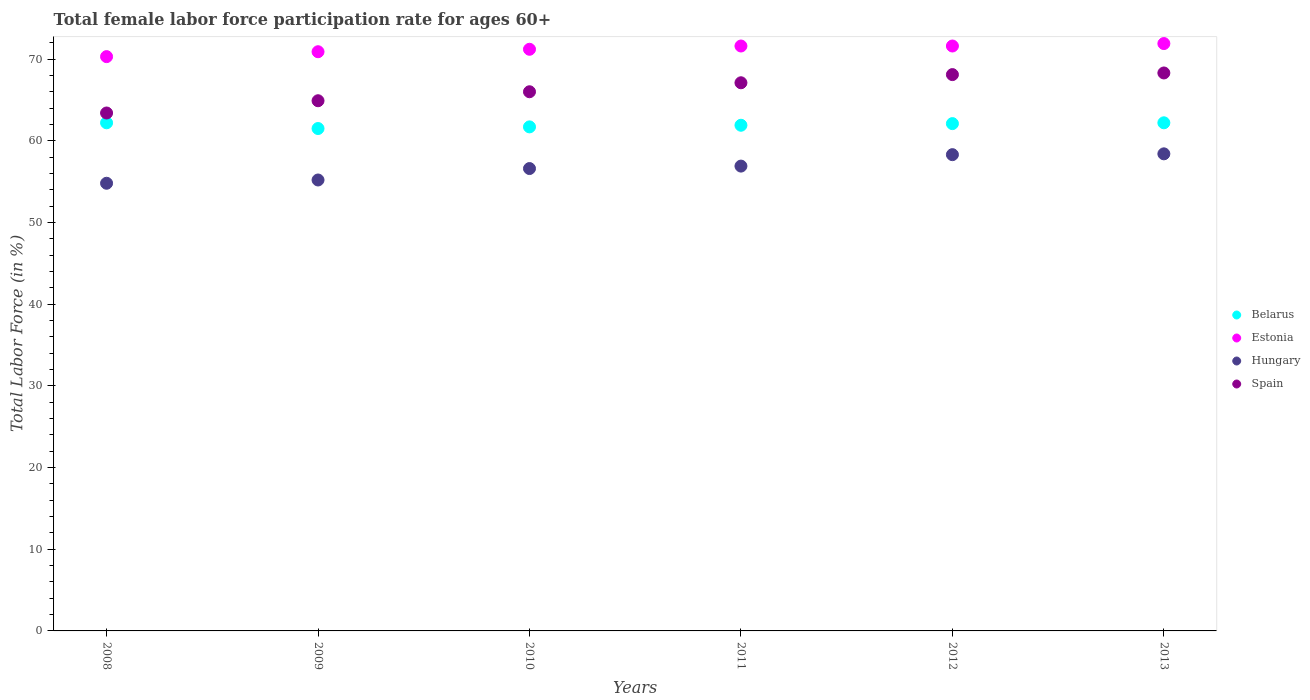How many different coloured dotlines are there?
Offer a very short reply. 4. Is the number of dotlines equal to the number of legend labels?
Ensure brevity in your answer.  Yes. What is the female labor force participation rate in Belarus in 2012?
Ensure brevity in your answer.  62.1. Across all years, what is the maximum female labor force participation rate in Hungary?
Provide a short and direct response. 58.4. Across all years, what is the minimum female labor force participation rate in Estonia?
Ensure brevity in your answer.  70.3. In which year was the female labor force participation rate in Spain minimum?
Give a very brief answer. 2008. What is the total female labor force participation rate in Hungary in the graph?
Offer a very short reply. 340.2. What is the difference between the female labor force participation rate in Estonia in 2008 and that in 2013?
Your answer should be very brief. -1.6. What is the average female labor force participation rate in Belarus per year?
Offer a terse response. 61.93. In the year 2012, what is the difference between the female labor force participation rate in Spain and female labor force participation rate in Hungary?
Your response must be concise. 9.8. What is the ratio of the female labor force participation rate in Estonia in 2011 to that in 2012?
Offer a terse response. 1. What is the difference between the highest and the second highest female labor force participation rate in Spain?
Keep it short and to the point. 0.2. What is the difference between the highest and the lowest female labor force participation rate in Spain?
Give a very brief answer. 4.9. In how many years, is the female labor force participation rate in Estonia greater than the average female labor force participation rate in Estonia taken over all years?
Make the answer very short. 3. Is it the case that in every year, the sum of the female labor force participation rate in Belarus and female labor force participation rate in Spain  is greater than the sum of female labor force participation rate in Estonia and female labor force participation rate in Hungary?
Provide a succinct answer. Yes. Does the female labor force participation rate in Spain monotonically increase over the years?
Keep it short and to the point. Yes. Is the female labor force participation rate in Hungary strictly less than the female labor force participation rate in Estonia over the years?
Give a very brief answer. Yes. How many dotlines are there?
Provide a short and direct response. 4. How many years are there in the graph?
Provide a short and direct response. 6. Are the values on the major ticks of Y-axis written in scientific E-notation?
Your answer should be compact. No. Does the graph contain grids?
Your answer should be compact. No. Where does the legend appear in the graph?
Keep it short and to the point. Center right. How many legend labels are there?
Your answer should be very brief. 4. What is the title of the graph?
Offer a terse response. Total female labor force participation rate for ages 60+. Does "Dominica" appear as one of the legend labels in the graph?
Offer a terse response. No. What is the label or title of the X-axis?
Offer a terse response. Years. What is the label or title of the Y-axis?
Ensure brevity in your answer.  Total Labor Force (in %). What is the Total Labor Force (in %) of Belarus in 2008?
Ensure brevity in your answer.  62.2. What is the Total Labor Force (in %) of Estonia in 2008?
Give a very brief answer. 70.3. What is the Total Labor Force (in %) of Hungary in 2008?
Your response must be concise. 54.8. What is the Total Labor Force (in %) of Spain in 2008?
Offer a very short reply. 63.4. What is the Total Labor Force (in %) of Belarus in 2009?
Ensure brevity in your answer.  61.5. What is the Total Labor Force (in %) of Estonia in 2009?
Offer a very short reply. 70.9. What is the Total Labor Force (in %) of Hungary in 2009?
Your answer should be compact. 55.2. What is the Total Labor Force (in %) in Spain in 2009?
Offer a terse response. 64.9. What is the Total Labor Force (in %) in Belarus in 2010?
Provide a short and direct response. 61.7. What is the Total Labor Force (in %) of Estonia in 2010?
Keep it short and to the point. 71.2. What is the Total Labor Force (in %) of Hungary in 2010?
Make the answer very short. 56.6. What is the Total Labor Force (in %) of Belarus in 2011?
Your response must be concise. 61.9. What is the Total Labor Force (in %) in Estonia in 2011?
Ensure brevity in your answer.  71.6. What is the Total Labor Force (in %) of Hungary in 2011?
Provide a short and direct response. 56.9. What is the Total Labor Force (in %) of Spain in 2011?
Your response must be concise. 67.1. What is the Total Labor Force (in %) in Belarus in 2012?
Give a very brief answer. 62.1. What is the Total Labor Force (in %) of Estonia in 2012?
Offer a very short reply. 71.6. What is the Total Labor Force (in %) of Hungary in 2012?
Ensure brevity in your answer.  58.3. What is the Total Labor Force (in %) of Spain in 2012?
Make the answer very short. 68.1. What is the Total Labor Force (in %) of Belarus in 2013?
Make the answer very short. 62.2. What is the Total Labor Force (in %) of Estonia in 2013?
Provide a short and direct response. 71.9. What is the Total Labor Force (in %) in Hungary in 2013?
Your response must be concise. 58.4. What is the Total Labor Force (in %) of Spain in 2013?
Provide a succinct answer. 68.3. Across all years, what is the maximum Total Labor Force (in %) in Belarus?
Provide a short and direct response. 62.2. Across all years, what is the maximum Total Labor Force (in %) in Estonia?
Provide a short and direct response. 71.9. Across all years, what is the maximum Total Labor Force (in %) in Hungary?
Your response must be concise. 58.4. Across all years, what is the maximum Total Labor Force (in %) of Spain?
Make the answer very short. 68.3. Across all years, what is the minimum Total Labor Force (in %) of Belarus?
Offer a very short reply. 61.5. Across all years, what is the minimum Total Labor Force (in %) of Estonia?
Provide a short and direct response. 70.3. Across all years, what is the minimum Total Labor Force (in %) of Hungary?
Your answer should be compact. 54.8. Across all years, what is the minimum Total Labor Force (in %) of Spain?
Your response must be concise. 63.4. What is the total Total Labor Force (in %) in Belarus in the graph?
Your response must be concise. 371.6. What is the total Total Labor Force (in %) of Estonia in the graph?
Give a very brief answer. 427.5. What is the total Total Labor Force (in %) of Hungary in the graph?
Your response must be concise. 340.2. What is the total Total Labor Force (in %) of Spain in the graph?
Make the answer very short. 397.8. What is the difference between the Total Labor Force (in %) of Estonia in 2008 and that in 2009?
Make the answer very short. -0.6. What is the difference between the Total Labor Force (in %) in Hungary in 2008 and that in 2010?
Provide a short and direct response. -1.8. What is the difference between the Total Labor Force (in %) of Belarus in 2008 and that in 2011?
Ensure brevity in your answer.  0.3. What is the difference between the Total Labor Force (in %) in Belarus in 2008 and that in 2012?
Keep it short and to the point. 0.1. What is the difference between the Total Labor Force (in %) in Belarus in 2008 and that in 2013?
Give a very brief answer. 0. What is the difference between the Total Labor Force (in %) in Spain in 2009 and that in 2010?
Your response must be concise. -1.1. What is the difference between the Total Labor Force (in %) of Belarus in 2009 and that in 2011?
Offer a very short reply. -0.4. What is the difference between the Total Labor Force (in %) in Hungary in 2009 and that in 2011?
Offer a terse response. -1.7. What is the difference between the Total Labor Force (in %) of Spain in 2009 and that in 2011?
Provide a short and direct response. -2.2. What is the difference between the Total Labor Force (in %) of Hungary in 2009 and that in 2012?
Keep it short and to the point. -3.1. What is the difference between the Total Labor Force (in %) in Belarus in 2009 and that in 2013?
Ensure brevity in your answer.  -0.7. What is the difference between the Total Labor Force (in %) of Hungary in 2009 and that in 2013?
Provide a succinct answer. -3.2. What is the difference between the Total Labor Force (in %) in Spain in 2009 and that in 2013?
Offer a very short reply. -3.4. What is the difference between the Total Labor Force (in %) of Hungary in 2010 and that in 2011?
Keep it short and to the point. -0.3. What is the difference between the Total Labor Force (in %) of Spain in 2010 and that in 2011?
Offer a very short reply. -1.1. What is the difference between the Total Labor Force (in %) in Belarus in 2010 and that in 2012?
Your response must be concise. -0.4. What is the difference between the Total Labor Force (in %) in Hungary in 2010 and that in 2013?
Your answer should be compact. -1.8. What is the difference between the Total Labor Force (in %) in Belarus in 2011 and that in 2013?
Provide a succinct answer. -0.3. What is the difference between the Total Labor Force (in %) of Estonia in 2011 and that in 2013?
Offer a terse response. -0.3. What is the difference between the Total Labor Force (in %) of Hungary in 2011 and that in 2013?
Make the answer very short. -1.5. What is the difference between the Total Labor Force (in %) in Spain in 2011 and that in 2013?
Keep it short and to the point. -1.2. What is the difference between the Total Labor Force (in %) of Belarus in 2012 and that in 2013?
Give a very brief answer. -0.1. What is the difference between the Total Labor Force (in %) in Estonia in 2012 and that in 2013?
Your answer should be compact. -0.3. What is the difference between the Total Labor Force (in %) in Belarus in 2008 and the Total Labor Force (in %) in Hungary in 2009?
Offer a very short reply. 7. What is the difference between the Total Labor Force (in %) in Estonia in 2008 and the Total Labor Force (in %) in Hungary in 2009?
Offer a terse response. 15.1. What is the difference between the Total Labor Force (in %) in Estonia in 2008 and the Total Labor Force (in %) in Spain in 2009?
Your answer should be compact. 5.4. What is the difference between the Total Labor Force (in %) in Hungary in 2008 and the Total Labor Force (in %) in Spain in 2009?
Offer a terse response. -10.1. What is the difference between the Total Labor Force (in %) of Belarus in 2008 and the Total Labor Force (in %) of Estonia in 2010?
Offer a very short reply. -9. What is the difference between the Total Labor Force (in %) of Estonia in 2008 and the Total Labor Force (in %) of Hungary in 2010?
Offer a very short reply. 13.7. What is the difference between the Total Labor Force (in %) of Belarus in 2008 and the Total Labor Force (in %) of Estonia in 2011?
Ensure brevity in your answer.  -9.4. What is the difference between the Total Labor Force (in %) of Estonia in 2008 and the Total Labor Force (in %) of Spain in 2011?
Your response must be concise. 3.2. What is the difference between the Total Labor Force (in %) of Hungary in 2008 and the Total Labor Force (in %) of Spain in 2011?
Provide a succinct answer. -12.3. What is the difference between the Total Labor Force (in %) in Belarus in 2008 and the Total Labor Force (in %) in Estonia in 2012?
Give a very brief answer. -9.4. What is the difference between the Total Labor Force (in %) of Estonia in 2008 and the Total Labor Force (in %) of Hungary in 2012?
Ensure brevity in your answer.  12. What is the difference between the Total Labor Force (in %) in Estonia in 2008 and the Total Labor Force (in %) in Spain in 2012?
Your response must be concise. 2.2. What is the difference between the Total Labor Force (in %) of Hungary in 2008 and the Total Labor Force (in %) of Spain in 2012?
Your answer should be compact. -13.3. What is the difference between the Total Labor Force (in %) in Belarus in 2008 and the Total Labor Force (in %) in Hungary in 2013?
Ensure brevity in your answer.  3.8. What is the difference between the Total Labor Force (in %) in Estonia in 2008 and the Total Labor Force (in %) in Hungary in 2013?
Your answer should be compact. 11.9. What is the difference between the Total Labor Force (in %) of Estonia in 2008 and the Total Labor Force (in %) of Spain in 2013?
Your answer should be very brief. 2. What is the difference between the Total Labor Force (in %) in Hungary in 2008 and the Total Labor Force (in %) in Spain in 2013?
Your answer should be compact. -13.5. What is the difference between the Total Labor Force (in %) of Belarus in 2009 and the Total Labor Force (in %) of Hungary in 2010?
Your response must be concise. 4.9. What is the difference between the Total Labor Force (in %) in Estonia in 2009 and the Total Labor Force (in %) in Hungary in 2010?
Offer a very short reply. 14.3. What is the difference between the Total Labor Force (in %) of Hungary in 2009 and the Total Labor Force (in %) of Spain in 2010?
Your answer should be compact. -10.8. What is the difference between the Total Labor Force (in %) of Belarus in 2009 and the Total Labor Force (in %) of Estonia in 2011?
Your answer should be compact. -10.1. What is the difference between the Total Labor Force (in %) of Belarus in 2009 and the Total Labor Force (in %) of Spain in 2011?
Your answer should be very brief. -5.6. What is the difference between the Total Labor Force (in %) in Estonia in 2009 and the Total Labor Force (in %) in Hungary in 2011?
Your answer should be compact. 14. What is the difference between the Total Labor Force (in %) of Belarus in 2009 and the Total Labor Force (in %) of Estonia in 2012?
Make the answer very short. -10.1. What is the difference between the Total Labor Force (in %) of Belarus in 2009 and the Total Labor Force (in %) of Spain in 2012?
Give a very brief answer. -6.6. What is the difference between the Total Labor Force (in %) in Estonia in 2009 and the Total Labor Force (in %) in Hungary in 2012?
Provide a succinct answer. 12.6. What is the difference between the Total Labor Force (in %) in Hungary in 2009 and the Total Labor Force (in %) in Spain in 2012?
Offer a terse response. -12.9. What is the difference between the Total Labor Force (in %) in Belarus in 2009 and the Total Labor Force (in %) in Hungary in 2013?
Give a very brief answer. 3.1. What is the difference between the Total Labor Force (in %) in Estonia in 2009 and the Total Labor Force (in %) in Hungary in 2013?
Keep it short and to the point. 12.5. What is the difference between the Total Labor Force (in %) in Estonia in 2009 and the Total Labor Force (in %) in Spain in 2013?
Ensure brevity in your answer.  2.6. What is the difference between the Total Labor Force (in %) of Hungary in 2009 and the Total Labor Force (in %) of Spain in 2013?
Offer a very short reply. -13.1. What is the difference between the Total Labor Force (in %) of Belarus in 2010 and the Total Labor Force (in %) of Estonia in 2011?
Provide a short and direct response. -9.9. What is the difference between the Total Labor Force (in %) in Belarus in 2010 and the Total Labor Force (in %) in Spain in 2011?
Provide a succinct answer. -5.4. What is the difference between the Total Labor Force (in %) of Estonia in 2010 and the Total Labor Force (in %) of Hungary in 2011?
Offer a terse response. 14.3. What is the difference between the Total Labor Force (in %) of Hungary in 2010 and the Total Labor Force (in %) of Spain in 2011?
Your answer should be very brief. -10.5. What is the difference between the Total Labor Force (in %) in Belarus in 2010 and the Total Labor Force (in %) in Estonia in 2012?
Keep it short and to the point. -9.9. What is the difference between the Total Labor Force (in %) in Estonia in 2010 and the Total Labor Force (in %) in Hungary in 2012?
Provide a short and direct response. 12.9. What is the difference between the Total Labor Force (in %) of Belarus in 2010 and the Total Labor Force (in %) of Hungary in 2013?
Offer a very short reply. 3.3. What is the difference between the Total Labor Force (in %) in Belarus in 2011 and the Total Labor Force (in %) in Hungary in 2012?
Provide a short and direct response. 3.6. What is the difference between the Total Labor Force (in %) in Belarus in 2011 and the Total Labor Force (in %) in Spain in 2012?
Give a very brief answer. -6.2. What is the difference between the Total Labor Force (in %) of Hungary in 2011 and the Total Labor Force (in %) of Spain in 2012?
Ensure brevity in your answer.  -11.2. What is the difference between the Total Labor Force (in %) in Belarus in 2011 and the Total Labor Force (in %) in Hungary in 2013?
Keep it short and to the point. 3.5. What is the difference between the Total Labor Force (in %) of Estonia in 2011 and the Total Labor Force (in %) of Hungary in 2013?
Give a very brief answer. 13.2. What is the difference between the Total Labor Force (in %) of Estonia in 2011 and the Total Labor Force (in %) of Spain in 2013?
Keep it short and to the point. 3.3. What is the difference between the Total Labor Force (in %) in Hungary in 2011 and the Total Labor Force (in %) in Spain in 2013?
Your answer should be compact. -11.4. What is the difference between the Total Labor Force (in %) of Belarus in 2012 and the Total Labor Force (in %) of Estonia in 2013?
Your answer should be compact. -9.8. What is the difference between the Total Labor Force (in %) of Belarus in 2012 and the Total Labor Force (in %) of Hungary in 2013?
Give a very brief answer. 3.7. What is the difference between the Total Labor Force (in %) of Estonia in 2012 and the Total Labor Force (in %) of Hungary in 2013?
Offer a very short reply. 13.2. What is the difference between the Total Labor Force (in %) of Hungary in 2012 and the Total Labor Force (in %) of Spain in 2013?
Keep it short and to the point. -10. What is the average Total Labor Force (in %) of Belarus per year?
Provide a succinct answer. 61.93. What is the average Total Labor Force (in %) in Estonia per year?
Your answer should be very brief. 71.25. What is the average Total Labor Force (in %) in Hungary per year?
Ensure brevity in your answer.  56.7. What is the average Total Labor Force (in %) in Spain per year?
Keep it short and to the point. 66.3. In the year 2008, what is the difference between the Total Labor Force (in %) of Estonia and Total Labor Force (in %) of Spain?
Ensure brevity in your answer.  6.9. In the year 2008, what is the difference between the Total Labor Force (in %) in Hungary and Total Labor Force (in %) in Spain?
Provide a succinct answer. -8.6. In the year 2009, what is the difference between the Total Labor Force (in %) in Estonia and Total Labor Force (in %) in Spain?
Your answer should be compact. 6. In the year 2010, what is the difference between the Total Labor Force (in %) in Belarus and Total Labor Force (in %) in Hungary?
Offer a very short reply. 5.1. In the year 2010, what is the difference between the Total Labor Force (in %) of Estonia and Total Labor Force (in %) of Hungary?
Your answer should be compact. 14.6. In the year 2010, what is the difference between the Total Labor Force (in %) in Estonia and Total Labor Force (in %) in Spain?
Keep it short and to the point. 5.2. In the year 2011, what is the difference between the Total Labor Force (in %) in Belarus and Total Labor Force (in %) in Estonia?
Offer a very short reply. -9.7. In the year 2011, what is the difference between the Total Labor Force (in %) of Belarus and Total Labor Force (in %) of Hungary?
Your answer should be compact. 5. In the year 2011, what is the difference between the Total Labor Force (in %) of Belarus and Total Labor Force (in %) of Spain?
Ensure brevity in your answer.  -5.2. In the year 2011, what is the difference between the Total Labor Force (in %) of Estonia and Total Labor Force (in %) of Hungary?
Your response must be concise. 14.7. In the year 2011, what is the difference between the Total Labor Force (in %) in Estonia and Total Labor Force (in %) in Spain?
Keep it short and to the point. 4.5. In the year 2011, what is the difference between the Total Labor Force (in %) of Hungary and Total Labor Force (in %) of Spain?
Your answer should be compact. -10.2. In the year 2012, what is the difference between the Total Labor Force (in %) in Estonia and Total Labor Force (in %) in Hungary?
Your response must be concise. 13.3. In the year 2012, what is the difference between the Total Labor Force (in %) of Estonia and Total Labor Force (in %) of Spain?
Your answer should be very brief. 3.5. In the year 2012, what is the difference between the Total Labor Force (in %) in Hungary and Total Labor Force (in %) in Spain?
Provide a succinct answer. -9.8. In the year 2013, what is the difference between the Total Labor Force (in %) of Belarus and Total Labor Force (in %) of Hungary?
Your answer should be very brief. 3.8. In the year 2013, what is the difference between the Total Labor Force (in %) of Estonia and Total Labor Force (in %) of Hungary?
Your answer should be very brief. 13.5. In the year 2013, what is the difference between the Total Labor Force (in %) of Estonia and Total Labor Force (in %) of Spain?
Ensure brevity in your answer.  3.6. What is the ratio of the Total Labor Force (in %) of Belarus in 2008 to that in 2009?
Your answer should be very brief. 1.01. What is the ratio of the Total Labor Force (in %) of Spain in 2008 to that in 2009?
Your answer should be very brief. 0.98. What is the ratio of the Total Labor Force (in %) of Belarus in 2008 to that in 2010?
Offer a very short reply. 1.01. What is the ratio of the Total Labor Force (in %) of Estonia in 2008 to that in 2010?
Ensure brevity in your answer.  0.99. What is the ratio of the Total Labor Force (in %) of Hungary in 2008 to that in 2010?
Offer a very short reply. 0.97. What is the ratio of the Total Labor Force (in %) of Spain in 2008 to that in 2010?
Ensure brevity in your answer.  0.96. What is the ratio of the Total Labor Force (in %) of Estonia in 2008 to that in 2011?
Make the answer very short. 0.98. What is the ratio of the Total Labor Force (in %) of Hungary in 2008 to that in 2011?
Make the answer very short. 0.96. What is the ratio of the Total Labor Force (in %) of Spain in 2008 to that in 2011?
Offer a very short reply. 0.94. What is the ratio of the Total Labor Force (in %) in Belarus in 2008 to that in 2012?
Your response must be concise. 1. What is the ratio of the Total Labor Force (in %) of Estonia in 2008 to that in 2012?
Your answer should be very brief. 0.98. What is the ratio of the Total Labor Force (in %) of Hungary in 2008 to that in 2012?
Provide a short and direct response. 0.94. What is the ratio of the Total Labor Force (in %) of Belarus in 2008 to that in 2013?
Provide a short and direct response. 1. What is the ratio of the Total Labor Force (in %) of Estonia in 2008 to that in 2013?
Offer a terse response. 0.98. What is the ratio of the Total Labor Force (in %) in Hungary in 2008 to that in 2013?
Your answer should be very brief. 0.94. What is the ratio of the Total Labor Force (in %) of Spain in 2008 to that in 2013?
Provide a short and direct response. 0.93. What is the ratio of the Total Labor Force (in %) of Estonia in 2009 to that in 2010?
Give a very brief answer. 1. What is the ratio of the Total Labor Force (in %) of Hungary in 2009 to that in 2010?
Your answer should be very brief. 0.98. What is the ratio of the Total Labor Force (in %) in Spain in 2009 to that in 2010?
Provide a succinct answer. 0.98. What is the ratio of the Total Labor Force (in %) in Belarus in 2009 to that in 2011?
Offer a very short reply. 0.99. What is the ratio of the Total Labor Force (in %) in Estonia in 2009 to that in 2011?
Your response must be concise. 0.99. What is the ratio of the Total Labor Force (in %) of Hungary in 2009 to that in 2011?
Provide a short and direct response. 0.97. What is the ratio of the Total Labor Force (in %) of Spain in 2009 to that in 2011?
Your response must be concise. 0.97. What is the ratio of the Total Labor Force (in %) of Belarus in 2009 to that in 2012?
Give a very brief answer. 0.99. What is the ratio of the Total Labor Force (in %) of Estonia in 2009 to that in 2012?
Your response must be concise. 0.99. What is the ratio of the Total Labor Force (in %) in Hungary in 2009 to that in 2012?
Offer a very short reply. 0.95. What is the ratio of the Total Labor Force (in %) of Spain in 2009 to that in 2012?
Provide a short and direct response. 0.95. What is the ratio of the Total Labor Force (in %) in Belarus in 2009 to that in 2013?
Offer a terse response. 0.99. What is the ratio of the Total Labor Force (in %) in Estonia in 2009 to that in 2013?
Offer a terse response. 0.99. What is the ratio of the Total Labor Force (in %) in Hungary in 2009 to that in 2013?
Your answer should be compact. 0.95. What is the ratio of the Total Labor Force (in %) of Spain in 2009 to that in 2013?
Offer a terse response. 0.95. What is the ratio of the Total Labor Force (in %) in Spain in 2010 to that in 2011?
Provide a short and direct response. 0.98. What is the ratio of the Total Labor Force (in %) of Belarus in 2010 to that in 2012?
Keep it short and to the point. 0.99. What is the ratio of the Total Labor Force (in %) in Estonia in 2010 to that in 2012?
Give a very brief answer. 0.99. What is the ratio of the Total Labor Force (in %) in Hungary in 2010 to that in 2012?
Your response must be concise. 0.97. What is the ratio of the Total Labor Force (in %) in Spain in 2010 to that in 2012?
Your answer should be compact. 0.97. What is the ratio of the Total Labor Force (in %) in Belarus in 2010 to that in 2013?
Offer a very short reply. 0.99. What is the ratio of the Total Labor Force (in %) of Estonia in 2010 to that in 2013?
Your response must be concise. 0.99. What is the ratio of the Total Labor Force (in %) of Hungary in 2010 to that in 2013?
Your response must be concise. 0.97. What is the ratio of the Total Labor Force (in %) in Spain in 2010 to that in 2013?
Make the answer very short. 0.97. What is the ratio of the Total Labor Force (in %) of Estonia in 2011 to that in 2012?
Provide a short and direct response. 1. What is the ratio of the Total Labor Force (in %) in Belarus in 2011 to that in 2013?
Provide a succinct answer. 1. What is the ratio of the Total Labor Force (in %) in Hungary in 2011 to that in 2013?
Provide a succinct answer. 0.97. What is the ratio of the Total Labor Force (in %) in Spain in 2011 to that in 2013?
Your answer should be very brief. 0.98. What is the ratio of the Total Labor Force (in %) in Belarus in 2012 to that in 2013?
Provide a short and direct response. 1. What is the ratio of the Total Labor Force (in %) of Hungary in 2012 to that in 2013?
Provide a succinct answer. 1. What is the difference between the highest and the second highest Total Labor Force (in %) in Estonia?
Keep it short and to the point. 0.3. What is the difference between the highest and the second highest Total Labor Force (in %) in Spain?
Make the answer very short. 0.2. What is the difference between the highest and the lowest Total Labor Force (in %) in Estonia?
Give a very brief answer. 1.6. What is the difference between the highest and the lowest Total Labor Force (in %) in Hungary?
Provide a short and direct response. 3.6. 